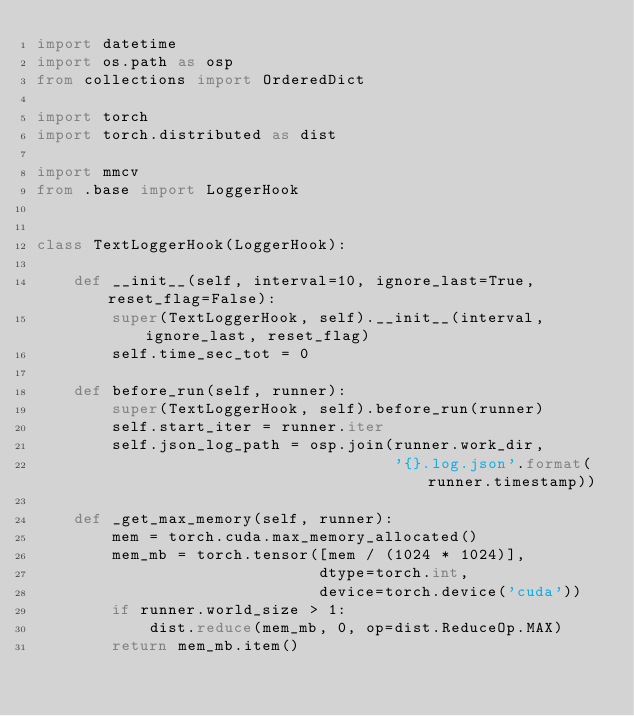<code> <loc_0><loc_0><loc_500><loc_500><_Python_>import datetime
import os.path as osp
from collections import OrderedDict

import torch
import torch.distributed as dist

import mmcv
from .base import LoggerHook


class TextLoggerHook(LoggerHook):

    def __init__(self, interval=10, ignore_last=True, reset_flag=False):
        super(TextLoggerHook, self).__init__(interval, ignore_last, reset_flag)
        self.time_sec_tot = 0

    def before_run(self, runner):
        super(TextLoggerHook, self).before_run(runner)
        self.start_iter = runner.iter
        self.json_log_path = osp.join(runner.work_dir,
                                      '{}.log.json'.format(runner.timestamp))

    def _get_max_memory(self, runner):
        mem = torch.cuda.max_memory_allocated()
        mem_mb = torch.tensor([mem / (1024 * 1024)],
                              dtype=torch.int,
                              device=torch.device('cuda'))
        if runner.world_size > 1:
            dist.reduce(mem_mb, 0, op=dist.ReduceOp.MAX)
        return mem_mb.item()
</code> 